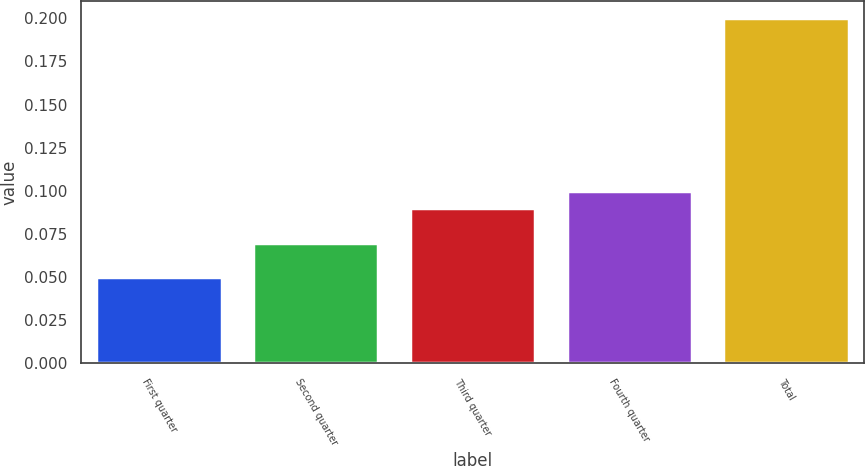Convert chart. <chart><loc_0><loc_0><loc_500><loc_500><bar_chart><fcel>First quarter<fcel>Second quarter<fcel>Third quarter<fcel>Fourth quarter<fcel>Total<nl><fcel>0.05<fcel>0.07<fcel>0.09<fcel>0.1<fcel>0.2<nl></chart> 